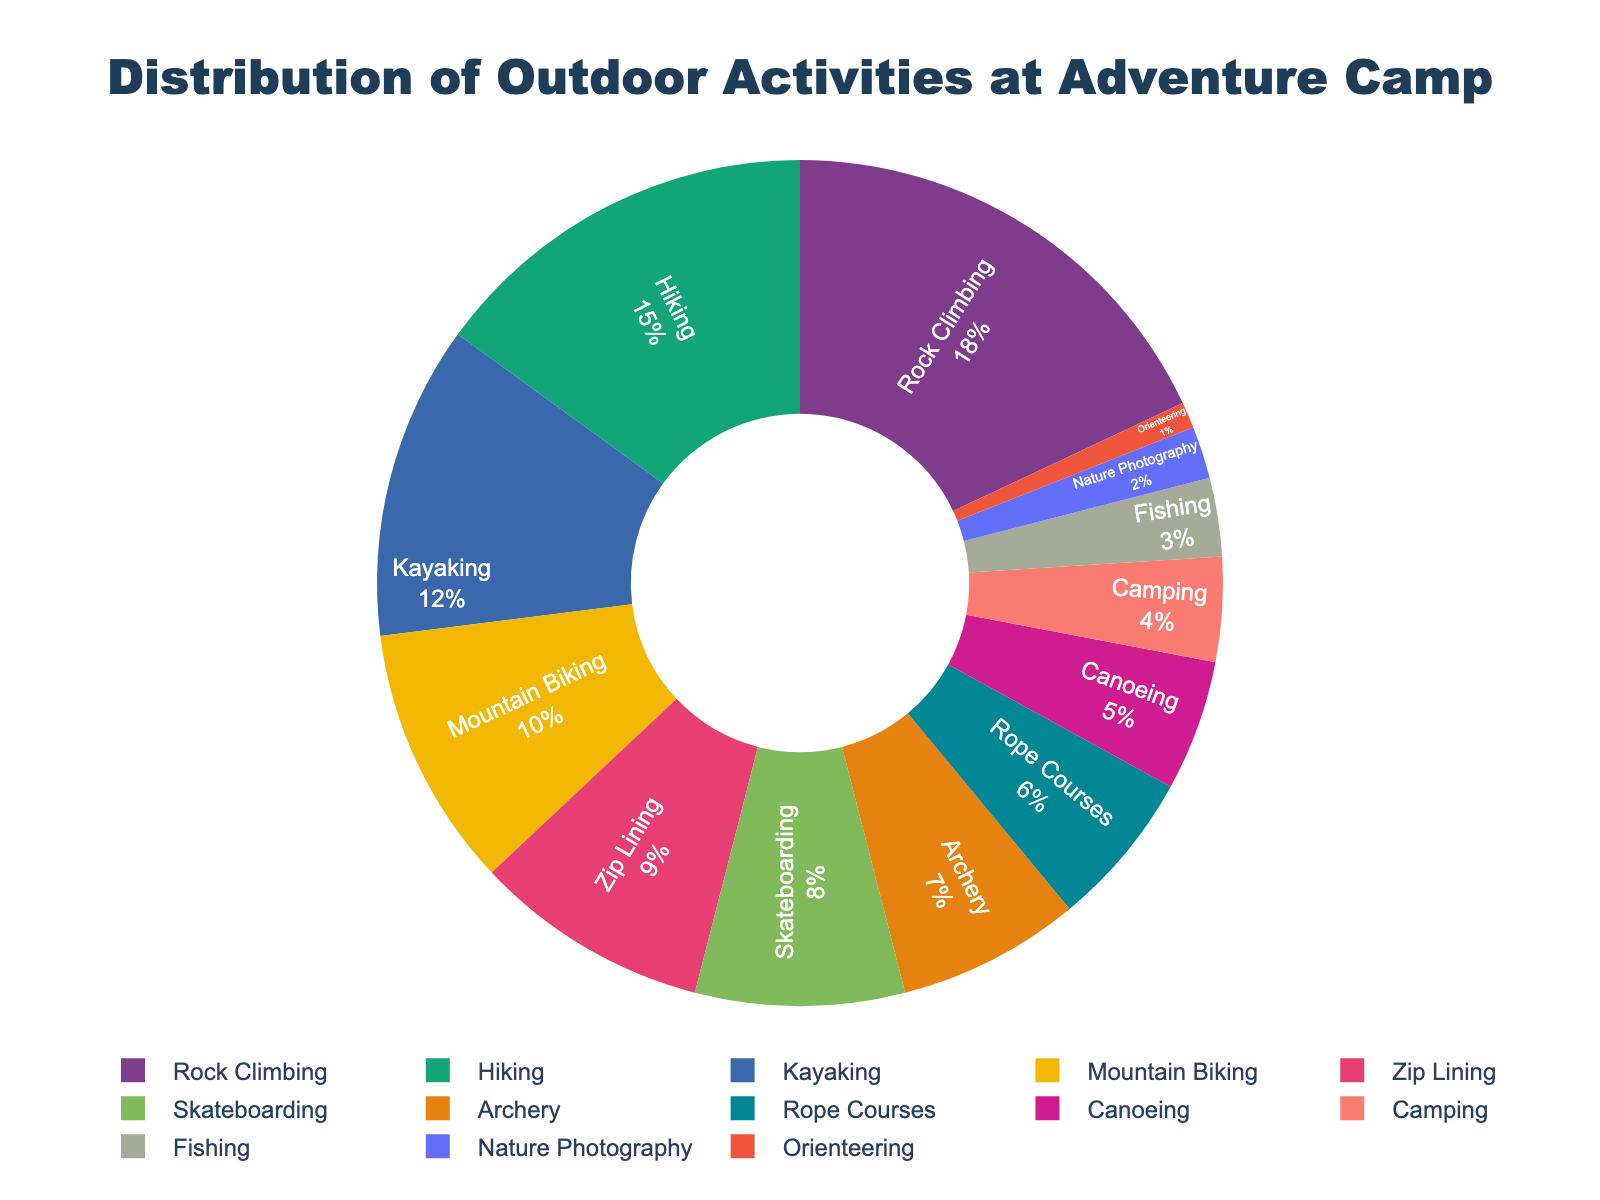Which outdoor activity has the highest percentage? Identify the activity with the largest slice in the pie chart. "Rock Climbing" has the largest slice, representing 18% of the activities.
Answer: Rock Climbing What is the sum of the percentages of the three least offered activities? Look at the three smallest slices: Orienteering (1%), Nature Photography (2%), and Fishing (3%). Add them: 1 + 2 + 3 = 6%.
Answer: 6% Which activity is more popular, Skateboarding or Archery? Compare the sizes of the slices for Skateboarding (8%) and Archery (7%). Skateboarding has a larger percentage, 8% vs. 7%.
Answer: Skateboarding What's the difference in percentage between the most and least offered activities? Subtract the smallest slice percentage (Orienteering, 1%) from the largest slice percentage (Rock Climbing, 18%). 18 - 1 = 17%.
Answer: 17% How many activities have a percentage of 10% or greater? Identify slices with 10% or more: Rock Climbing (18%), Hiking (15%), Kayaking (12%), Mountain Biking (10%). There are four such activities.
Answer: 4 Which activity occupies the smallest slice of the pie chart? Identify the activity with the smallest slice. Orienteering has the smallest slice, representing 1% of the activities.
Answer: Orienteering What is the combined percentage of activities related to water (Kayaking and Canoeing)? Add percentages for Kayaking (12%) and Canoeing (5%). 12 + 5 = 17%.
Answer: 17% Compare the combined percentage of rope-based activities (Rope Courses and Zip Lining) with that of Skateboarding. Which is higher and by how much? Add percentages for Rope Courses (6%) and Zip Lining (9%) to get 15%. Skateboarding is at 8%. The difference is 15 - 8 = 7%. Rope-based activities are higher by 7%.
Answer: Rope-based activities by 7% What is the average percentage of activities offered at the camp? Sum all the percentage values and divide by the number of activities: (18 + 15 + 12 + 10 + 9 + 8 + 7 + 6 + 5 + 4 + 3 + 2 + 1) / 13 = 100 / 13 ≈ 7.69%.
Answer: 7.69% 